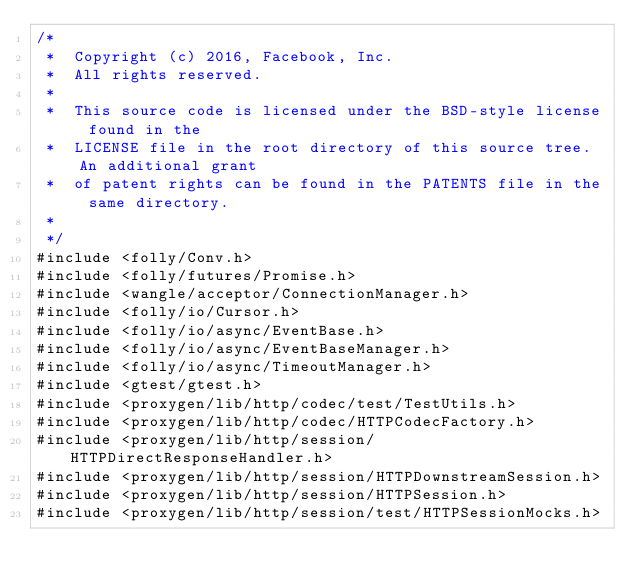<code> <loc_0><loc_0><loc_500><loc_500><_C++_>/*
 *  Copyright (c) 2016, Facebook, Inc.
 *  All rights reserved.
 *
 *  This source code is licensed under the BSD-style license found in the
 *  LICENSE file in the root directory of this source tree. An additional grant
 *  of patent rights can be found in the PATENTS file in the same directory.
 *
 */
#include <folly/Conv.h>
#include <folly/futures/Promise.h>
#include <wangle/acceptor/ConnectionManager.h>
#include <folly/io/Cursor.h>
#include <folly/io/async/EventBase.h>
#include <folly/io/async/EventBaseManager.h>
#include <folly/io/async/TimeoutManager.h>
#include <gtest/gtest.h>
#include <proxygen/lib/http/codec/test/TestUtils.h>
#include <proxygen/lib/http/codec/HTTPCodecFactory.h>
#include <proxygen/lib/http/session/HTTPDirectResponseHandler.h>
#include <proxygen/lib/http/session/HTTPDownstreamSession.h>
#include <proxygen/lib/http/session/HTTPSession.h>
#include <proxygen/lib/http/session/test/HTTPSessionMocks.h></code> 